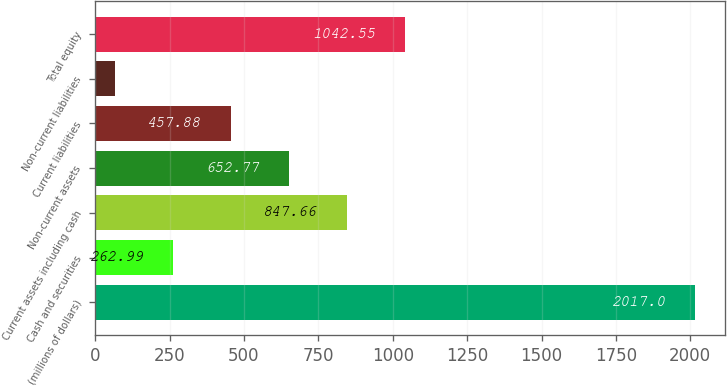Convert chart to OTSL. <chart><loc_0><loc_0><loc_500><loc_500><bar_chart><fcel>(millions of dollars)<fcel>Cash and securities<fcel>Current assets including cash<fcel>Non-current assets<fcel>Current liabilities<fcel>Non-current liabilities<fcel>Total equity<nl><fcel>2017<fcel>262.99<fcel>847.66<fcel>652.77<fcel>457.88<fcel>68.1<fcel>1042.55<nl></chart> 